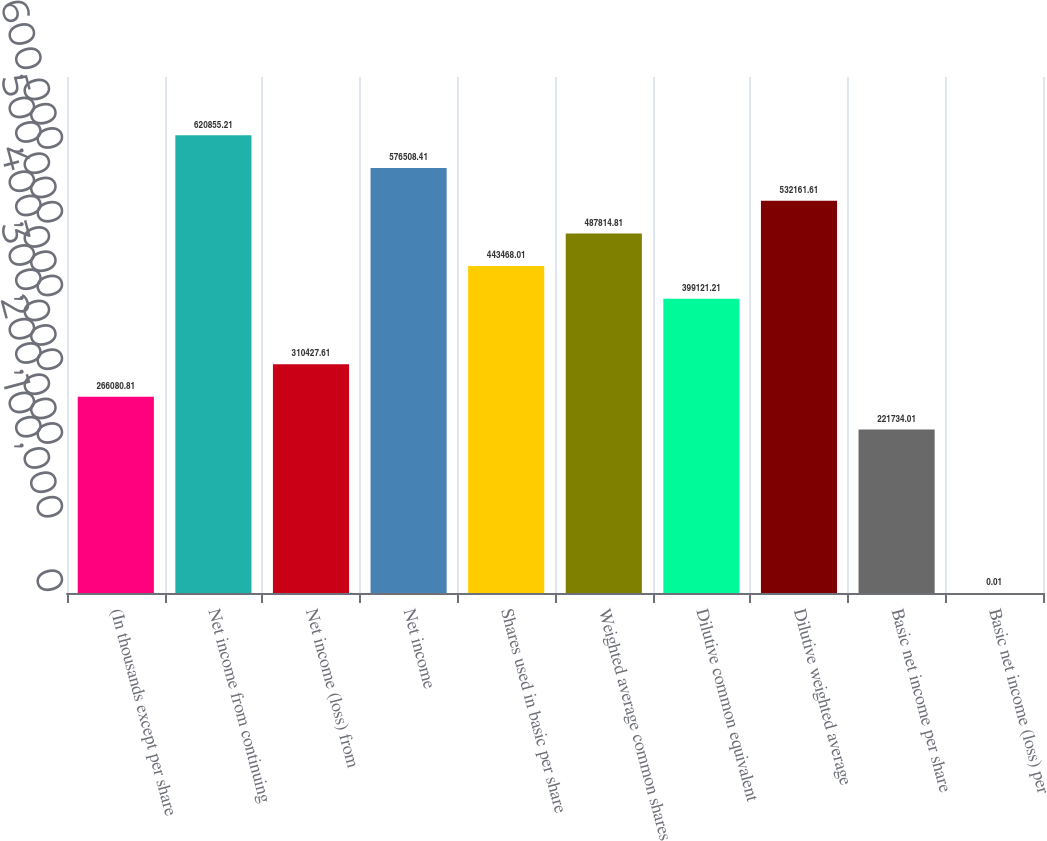Convert chart to OTSL. <chart><loc_0><loc_0><loc_500><loc_500><bar_chart><fcel>(In thousands except per share<fcel>Net income from continuing<fcel>Net income (loss) from<fcel>Net income<fcel>Shares used in basic per share<fcel>Weighted average common shares<fcel>Dilutive common equivalent<fcel>Dilutive weighted average<fcel>Basic net income per share<fcel>Basic net income (loss) per<nl><fcel>266081<fcel>620855<fcel>310428<fcel>576508<fcel>443468<fcel>487815<fcel>399121<fcel>532162<fcel>221734<fcel>0.01<nl></chart> 